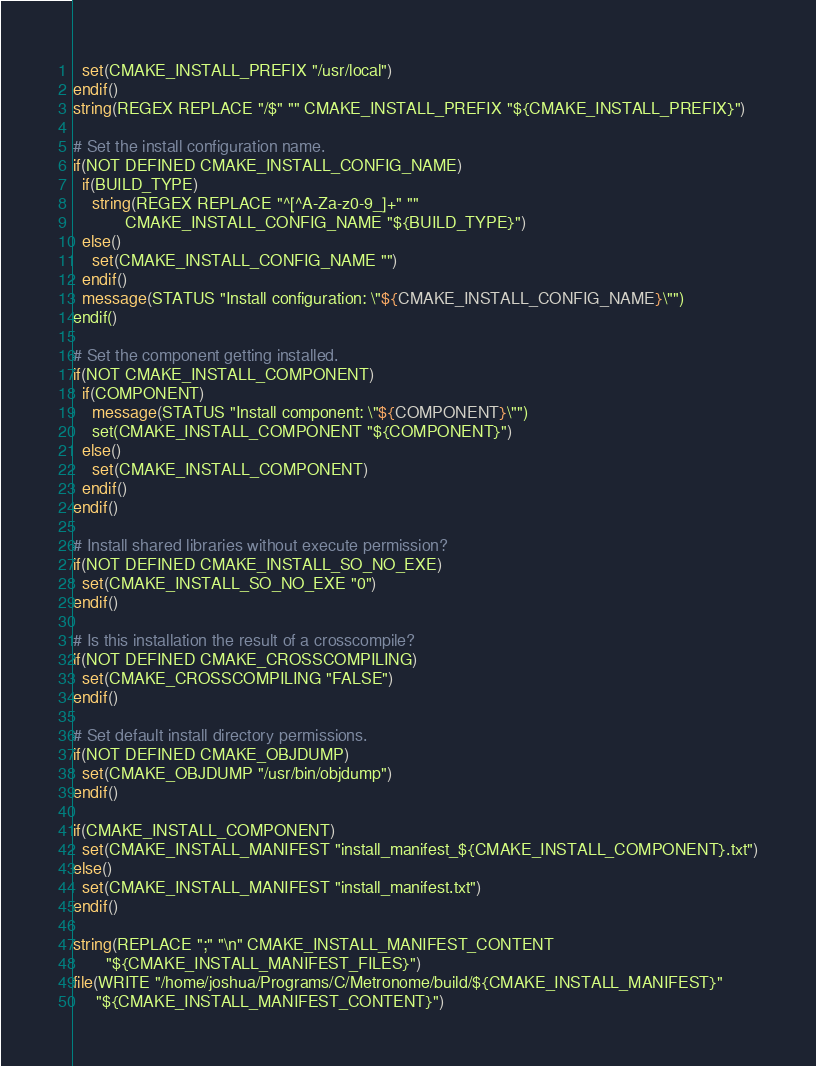Convert code to text. <code><loc_0><loc_0><loc_500><loc_500><_CMake_>  set(CMAKE_INSTALL_PREFIX "/usr/local")
endif()
string(REGEX REPLACE "/$" "" CMAKE_INSTALL_PREFIX "${CMAKE_INSTALL_PREFIX}")

# Set the install configuration name.
if(NOT DEFINED CMAKE_INSTALL_CONFIG_NAME)
  if(BUILD_TYPE)
    string(REGEX REPLACE "^[^A-Za-z0-9_]+" ""
           CMAKE_INSTALL_CONFIG_NAME "${BUILD_TYPE}")
  else()
    set(CMAKE_INSTALL_CONFIG_NAME "")
  endif()
  message(STATUS "Install configuration: \"${CMAKE_INSTALL_CONFIG_NAME}\"")
endif()

# Set the component getting installed.
if(NOT CMAKE_INSTALL_COMPONENT)
  if(COMPONENT)
    message(STATUS "Install component: \"${COMPONENT}\"")
    set(CMAKE_INSTALL_COMPONENT "${COMPONENT}")
  else()
    set(CMAKE_INSTALL_COMPONENT)
  endif()
endif()

# Install shared libraries without execute permission?
if(NOT DEFINED CMAKE_INSTALL_SO_NO_EXE)
  set(CMAKE_INSTALL_SO_NO_EXE "0")
endif()

# Is this installation the result of a crosscompile?
if(NOT DEFINED CMAKE_CROSSCOMPILING)
  set(CMAKE_CROSSCOMPILING "FALSE")
endif()

# Set default install directory permissions.
if(NOT DEFINED CMAKE_OBJDUMP)
  set(CMAKE_OBJDUMP "/usr/bin/objdump")
endif()

if(CMAKE_INSTALL_COMPONENT)
  set(CMAKE_INSTALL_MANIFEST "install_manifest_${CMAKE_INSTALL_COMPONENT}.txt")
else()
  set(CMAKE_INSTALL_MANIFEST "install_manifest.txt")
endif()

string(REPLACE ";" "\n" CMAKE_INSTALL_MANIFEST_CONTENT
       "${CMAKE_INSTALL_MANIFEST_FILES}")
file(WRITE "/home/joshua/Programs/C/Metronome/build/${CMAKE_INSTALL_MANIFEST}"
     "${CMAKE_INSTALL_MANIFEST_CONTENT}")
</code> 